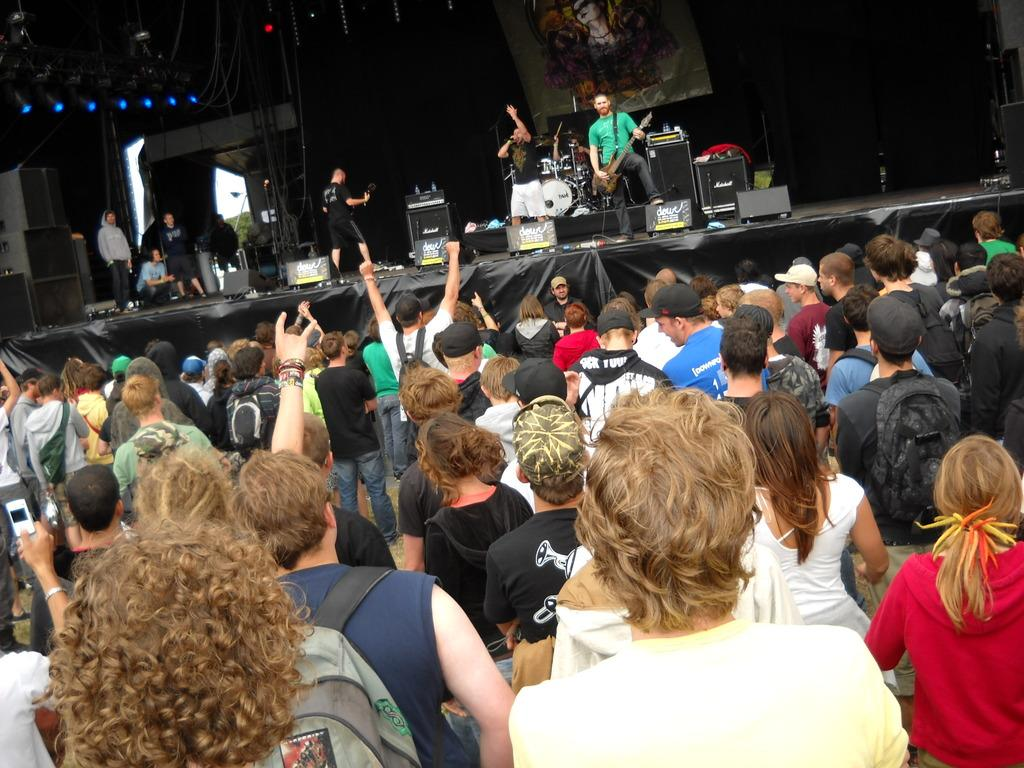What is happening in the image? There are people standing in the image, and some of them are performing on a stage. What can be seen on the stage? There is a stage in the image, and people are performing on it. Additionally, there are speakers on the stage. What might be the purpose of the speakers on the stage? The speakers on the stage might be used for amplifying sound during the performance. How many rabbits are sitting on the pear in the image? There are no rabbits or pears present in the image. What type of linen is draped over the stage in the image? There is no linen visible in the image; only the stage, speakers, and people are present. 